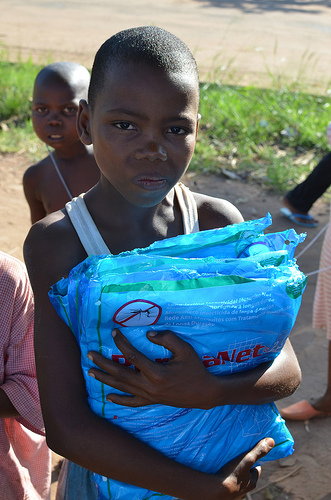<image>
Can you confirm if the grass is next to the bag? No. The grass is not positioned next to the bag. They are located in different areas of the scene. 